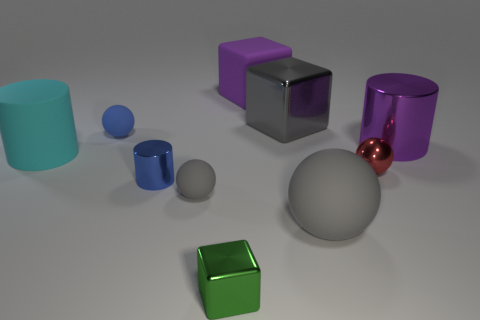What is the largest object in the image and can you describe its texture? The largest object in the image is a gray sphere, it has a matte texture which diffuses light, rather than reflecting it sharply like a glossy surface would. 